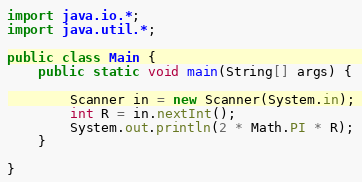<code> <loc_0><loc_0><loc_500><loc_500><_Java_>import java.io.*;
import java.util.*;

public class Main {
    public static void main(String[] args) {

        Scanner in = new Scanner(System.in);
        int R = in.nextInt();
        System.out.println(2 * Math.PI * R);
    }

}
</code> 